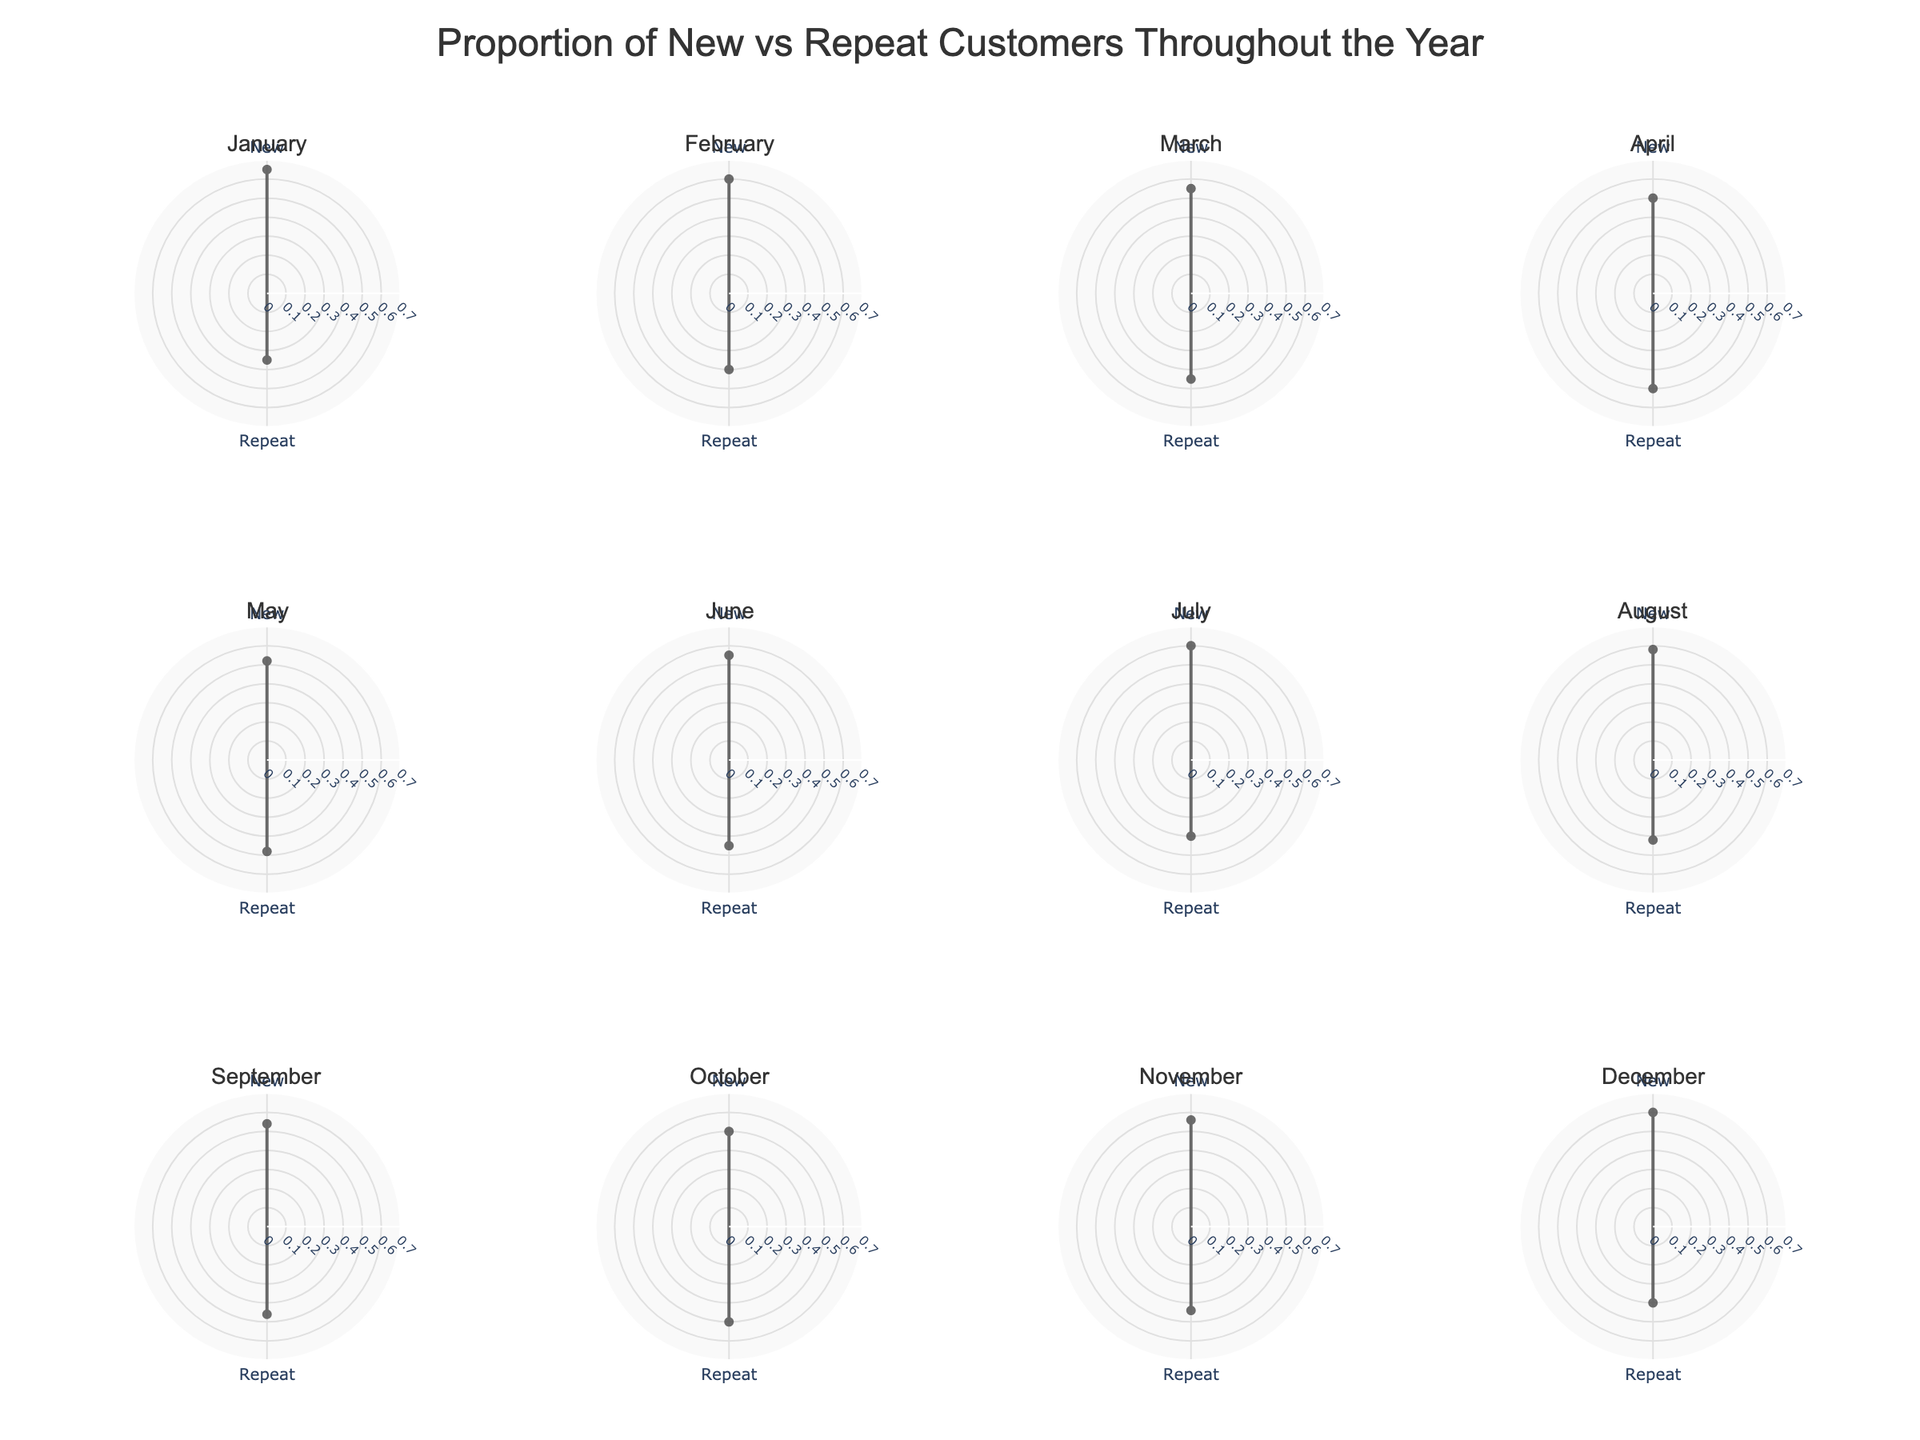What’s the title of the chart? The title is located at the top of the chart and is often in a larger and more prominent font.
Answer: Proportion of New vs Repeat Customers Throughout the Year Which month has the highest proportion of new customers? By scanning the values on the radial axis, January shows the highest proportion of new customers at 0.65.
Answer: January What is the proportion of repeat customers in October? Look at the October polar chart plot and find the proportion for “Repeat” which is 0.50.
Answer: 0.50 In which months do new and repeat customers have equal proportions? Identify the months where the proportions for both new and repeat customers are the same; in this case, both April and October.
Answer: April and October What is the average proportion of new customers from January to March? Sum the proportions of new customers from January (0.65), February (0.60), and March (0.55) and then divide by 3. (0.65 + 0.60 + 0.55) / 3 = 0.60.
Answer: 0.60 Which months see a decrease in the proportion of new customers compared to the previous month? Compare the proportions for new customers for each consecutive month. A decrease is observed in March (0.55 from 0.60 in February), April (0.50 from 0.55 in March), and September (0.54 from 0.58 in August).
Answer: March, April, September What is the difference in the proportion of new customers between July and November? Subtract the proportion of new customers in November (0.56) from that in July (0.60). 0.60 - 0.56 = 0.04.
Answer: 0.04 How does the proportion of repeat customers change from March to June? Note the values for repeat customers: March (0.45), April (0.50), May (0.48), June (0.45). There is an increase from March (0.45) to April (0.50), then a decrease to May (0.48), and returning to March’s value (0.45) in June.
Answer: Increases (March to April), decreases (April to May), stable (May to June) What pattern can be observed in the proportion of new customers over the year? An increasing trend is observed at the beginning of the year, followed by a slight dip and fluctuation in the middle, rising again toward the year's end but not reaching January’s peak value.
Answer: Fluctuating with initial increase, middle dip, and end-year rise Which month has the smallest difference between the proportion of new and repeat customers? Find the month where the proportions of new and repeat customers are closest to each other, which is the smallest difference. April and October both have a difference of 0 since they are equal.
Answer: April and October 